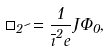Convert formula to latex. <formula><loc_0><loc_0><loc_500><loc_500>\square _ { 2 } \psi = \frac { 1 } { \overline { \zeta } ^ { 2 } e } J \Phi _ { 0 } ,</formula> 